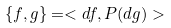Convert formula to latex. <formula><loc_0><loc_0><loc_500><loc_500>\{ f , g \} = < d f , P ( d g ) ></formula> 